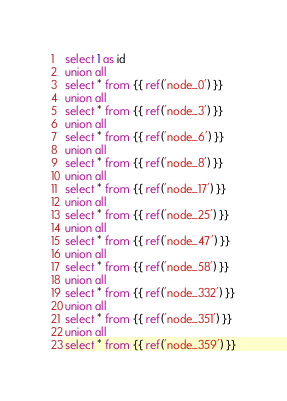<code> <loc_0><loc_0><loc_500><loc_500><_SQL_>select 1 as id
union all
select * from {{ ref('node_0') }}
union all
select * from {{ ref('node_3') }}
union all
select * from {{ ref('node_6') }}
union all
select * from {{ ref('node_8') }}
union all
select * from {{ ref('node_17') }}
union all
select * from {{ ref('node_25') }}
union all
select * from {{ ref('node_47') }}
union all
select * from {{ ref('node_58') }}
union all
select * from {{ ref('node_332') }}
union all
select * from {{ ref('node_351') }}
union all
select * from {{ ref('node_359') }}
</code> 